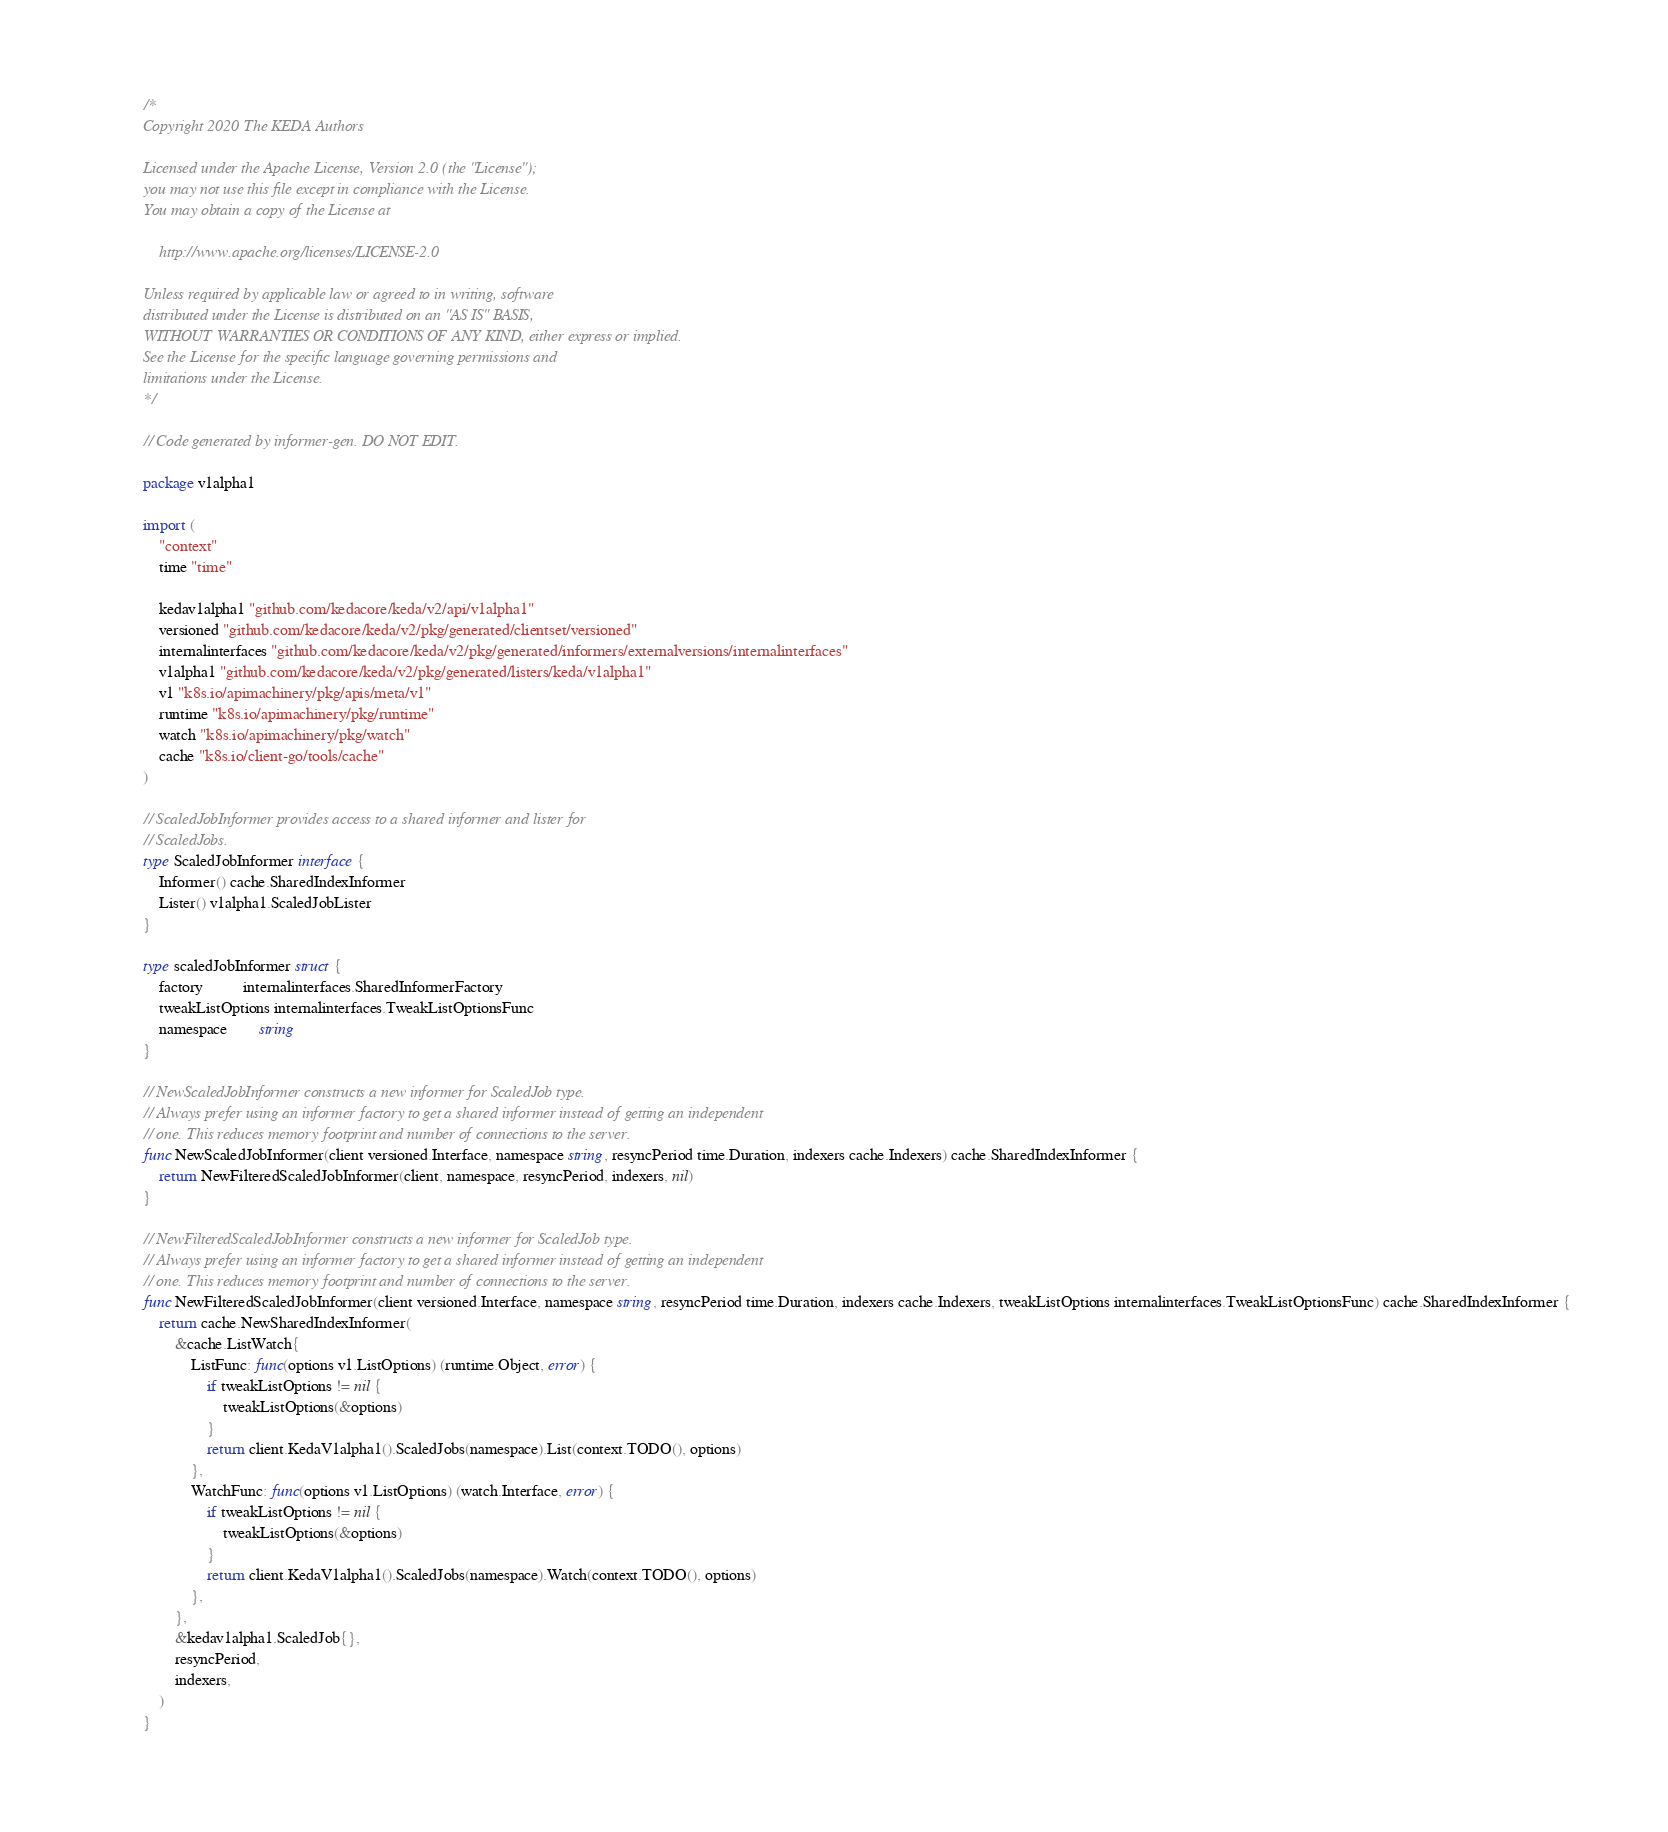Convert code to text. <code><loc_0><loc_0><loc_500><loc_500><_Go_>/*
Copyright 2020 The KEDA Authors

Licensed under the Apache License, Version 2.0 (the "License");
you may not use this file except in compliance with the License.
You may obtain a copy of the License at

    http://www.apache.org/licenses/LICENSE-2.0

Unless required by applicable law or agreed to in writing, software
distributed under the License is distributed on an "AS IS" BASIS,
WITHOUT WARRANTIES OR CONDITIONS OF ANY KIND, either express or implied.
See the License for the specific language governing permissions and
limitations under the License.
*/

// Code generated by informer-gen. DO NOT EDIT.

package v1alpha1

import (
	"context"
	time "time"

	kedav1alpha1 "github.com/kedacore/keda/v2/api/v1alpha1"
	versioned "github.com/kedacore/keda/v2/pkg/generated/clientset/versioned"
	internalinterfaces "github.com/kedacore/keda/v2/pkg/generated/informers/externalversions/internalinterfaces"
	v1alpha1 "github.com/kedacore/keda/v2/pkg/generated/listers/keda/v1alpha1"
	v1 "k8s.io/apimachinery/pkg/apis/meta/v1"
	runtime "k8s.io/apimachinery/pkg/runtime"
	watch "k8s.io/apimachinery/pkg/watch"
	cache "k8s.io/client-go/tools/cache"
)

// ScaledJobInformer provides access to a shared informer and lister for
// ScaledJobs.
type ScaledJobInformer interface {
	Informer() cache.SharedIndexInformer
	Lister() v1alpha1.ScaledJobLister
}

type scaledJobInformer struct {
	factory          internalinterfaces.SharedInformerFactory
	tweakListOptions internalinterfaces.TweakListOptionsFunc
	namespace        string
}

// NewScaledJobInformer constructs a new informer for ScaledJob type.
// Always prefer using an informer factory to get a shared informer instead of getting an independent
// one. This reduces memory footprint and number of connections to the server.
func NewScaledJobInformer(client versioned.Interface, namespace string, resyncPeriod time.Duration, indexers cache.Indexers) cache.SharedIndexInformer {
	return NewFilteredScaledJobInformer(client, namespace, resyncPeriod, indexers, nil)
}

// NewFilteredScaledJobInformer constructs a new informer for ScaledJob type.
// Always prefer using an informer factory to get a shared informer instead of getting an independent
// one. This reduces memory footprint and number of connections to the server.
func NewFilteredScaledJobInformer(client versioned.Interface, namespace string, resyncPeriod time.Duration, indexers cache.Indexers, tweakListOptions internalinterfaces.TweakListOptionsFunc) cache.SharedIndexInformer {
	return cache.NewSharedIndexInformer(
		&cache.ListWatch{
			ListFunc: func(options v1.ListOptions) (runtime.Object, error) {
				if tweakListOptions != nil {
					tweakListOptions(&options)
				}
				return client.KedaV1alpha1().ScaledJobs(namespace).List(context.TODO(), options)
			},
			WatchFunc: func(options v1.ListOptions) (watch.Interface, error) {
				if tweakListOptions != nil {
					tweakListOptions(&options)
				}
				return client.KedaV1alpha1().ScaledJobs(namespace).Watch(context.TODO(), options)
			},
		},
		&kedav1alpha1.ScaledJob{},
		resyncPeriod,
		indexers,
	)
}
</code> 